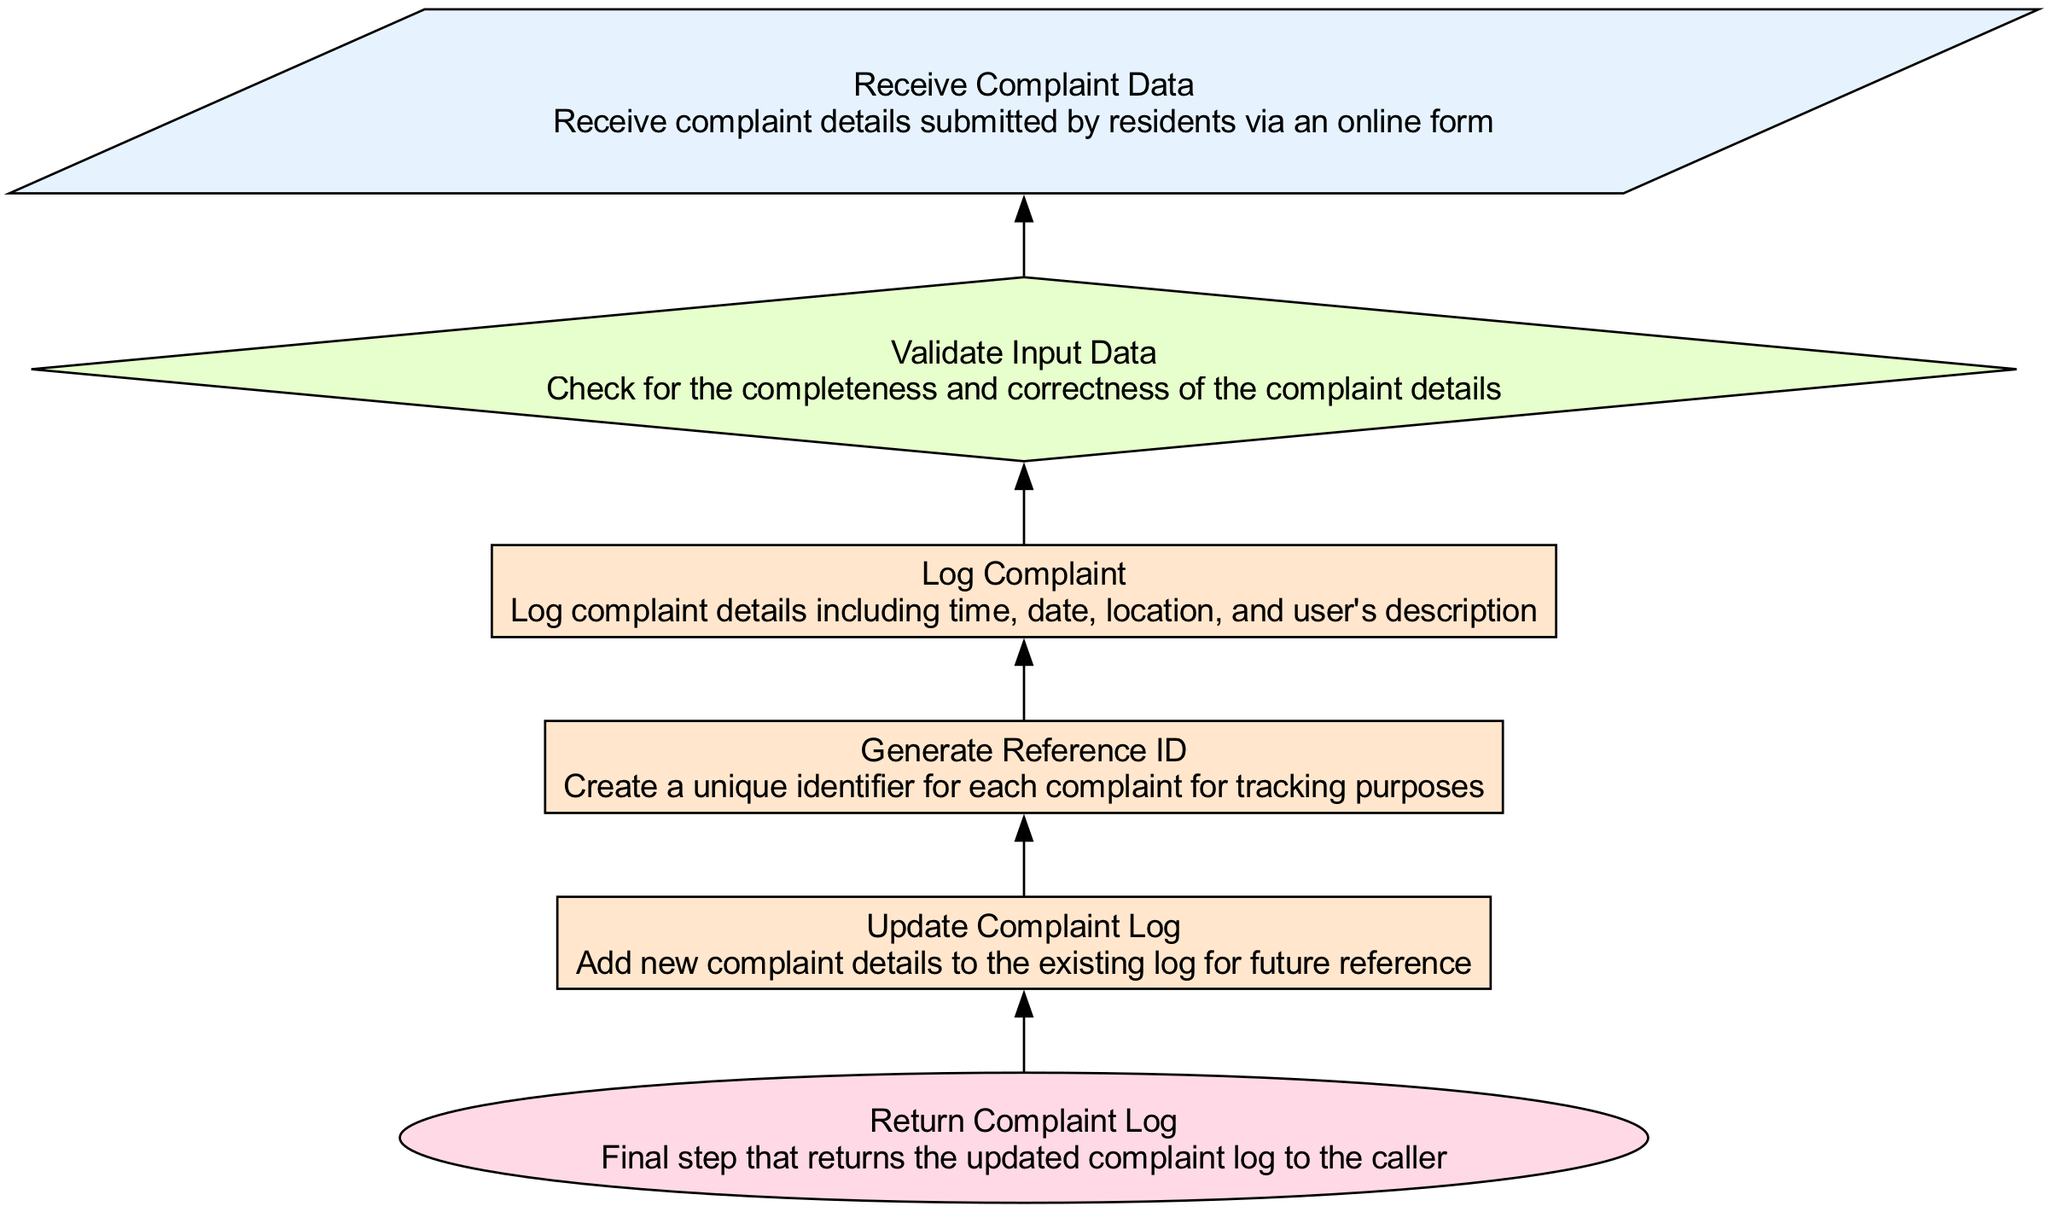What is the first step in the diagram? The first step, or input node, is "Receive Complaint Data", which indicates that the process begins by accepting complaint details from residents.
Answer: Receive Complaint Data How many total nodes are presented in the diagram? Counting all the nodes listed in the diagram (including input, process, decision, and return types), there are six nodes in total.
Answer: 6 What type of node is "Log Complaint"? "Log Complaint" is classified as a process node, indicating that this step involves a specific action that needs to be performed, such as logging details of the complaint.
Answer: process Which node comes after "Validate Input Data"? Following "Validate Input Data", the next step is "Log Complaint", indicating that once the input data is validated, the complaint is logged.
Answer: Log Complaint What is the purpose of the "Generate Reference ID" node? The purpose of "Generate Reference ID" is to create a unique identifier for each complaint, aiding in tracking and managing all complaints effectively.
Answer: Create a unique identifier How many edges are present in the diagram? The diagram shows five edges, representing the connections between the six nodes, as each edge represents a transition from one step to the next.
Answer: 5 What happens if the input data fails validation? Although not explicitly displayed, since "Validate Input Data" is a decision node, it generally implies that if validation fails, the process may not proceed to the next steps, remaining at this decision point until resolved.
Answer: Remains at decision point What is conveyed by the "Return Complaint Log" node? "Return Complaint Log" indicates the process's final step, which provides the updated log of complaints back to the caller or user, signaling the end of the function's execution.
Answer: Updated complaint log What type of relationship exists between "Log Complaint" and "Update Complaint Log"? "Log Complaint" leads sequentially to "Update Complaint Log", indicating that after logging the complaint details, the next logical step is to update the log with these new details.
Answer: Sequential relationship 